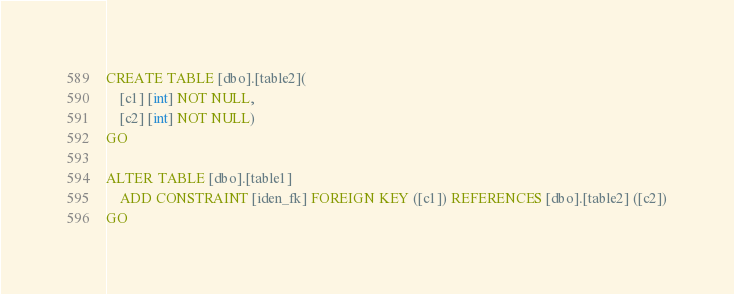Convert code to text. <code><loc_0><loc_0><loc_500><loc_500><_SQL_>CREATE TABLE [dbo].[table2](
    [c1] [int] NOT NULL,
    [c2] [int] NOT NULL)
GO

ALTER TABLE [dbo].[table1]
    ADD CONSTRAINT [iden_fk] FOREIGN KEY ([c1]) REFERENCES [dbo].[table2] ([c2])
GO</code> 